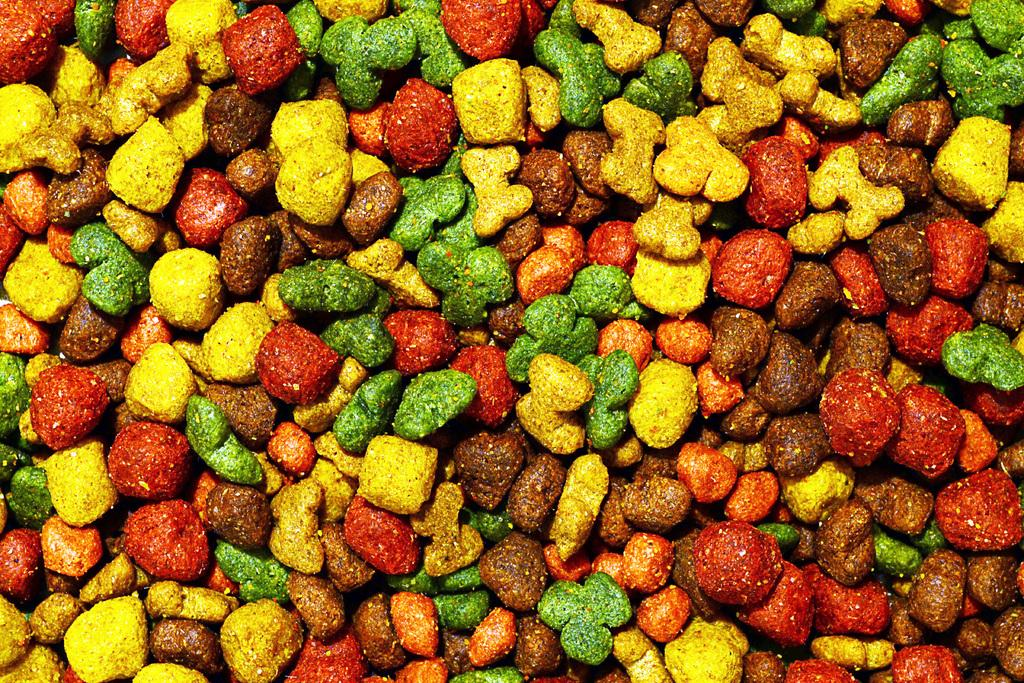What is the focus of the image? The subject of the image is colorful candies. Can you describe the level of detail in the image? The image is a zoomed in picture, which means it provides a close-up view of the candies. What type of juice is being poured over the candies in the image? There is no juice present in the image; it only features colorful candies. How many ladybugs can be seen crawling on the candies in the image? There are no ladybugs present in the image; it only features colorful candies. 